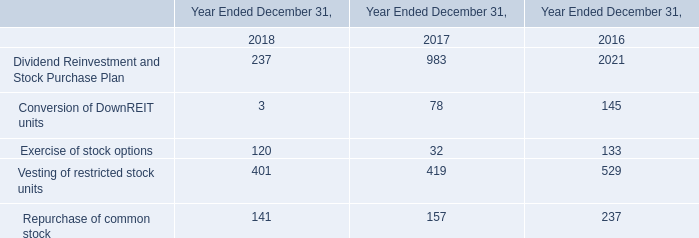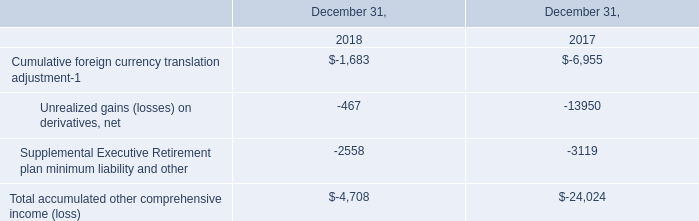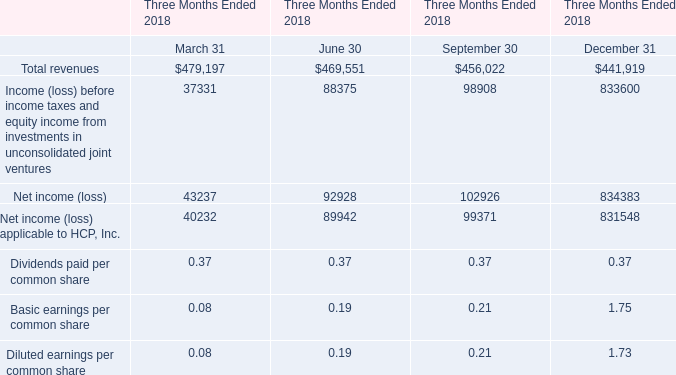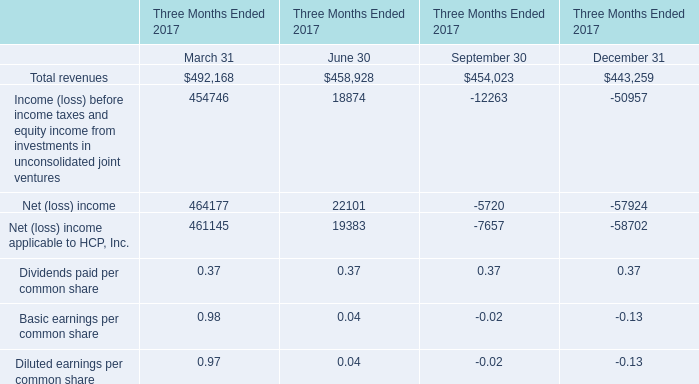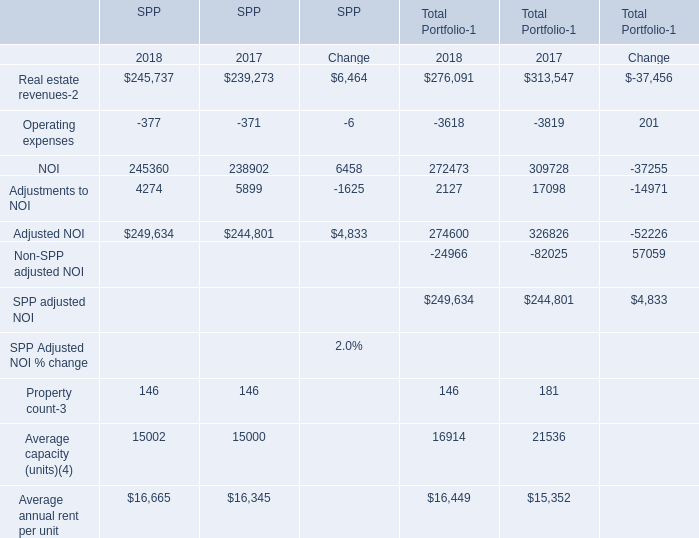What's the sum of the Total revenues in the years where Real estate revenues-2 for Total Portfolio-1 is greater than 300000? 
Computations: (((492168 + 458928) + 454023) + 443259)
Answer: 1848378.0. 